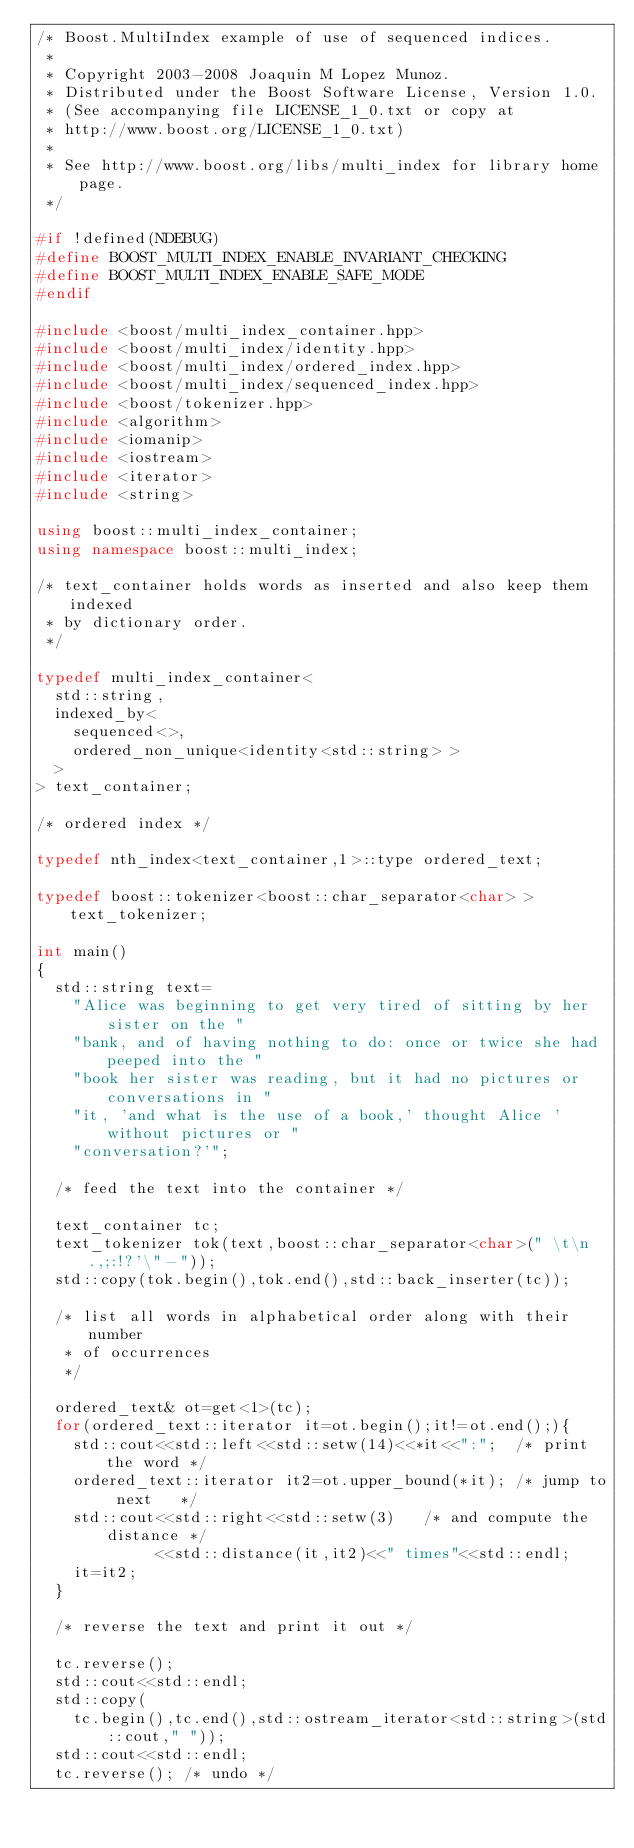<code> <loc_0><loc_0><loc_500><loc_500><_C++_>/* Boost.MultiIndex example of use of sequenced indices.
 *
 * Copyright 2003-2008 Joaquin M Lopez Munoz.
 * Distributed under the Boost Software License, Version 1.0.
 * (See accompanying file LICENSE_1_0.txt or copy at
 * http://www.boost.org/LICENSE_1_0.txt)
 *
 * See http://www.boost.org/libs/multi_index for library home page.
 */

#if !defined(NDEBUG)
#define BOOST_MULTI_INDEX_ENABLE_INVARIANT_CHECKING
#define BOOST_MULTI_INDEX_ENABLE_SAFE_MODE
#endif

#include <boost/multi_index_container.hpp>
#include <boost/multi_index/identity.hpp>
#include <boost/multi_index/ordered_index.hpp>
#include <boost/multi_index/sequenced_index.hpp>
#include <boost/tokenizer.hpp>
#include <algorithm>
#include <iomanip>
#include <iostream>
#include <iterator>
#include <string>

using boost::multi_index_container;
using namespace boost::multi_index;

/* text_container holds words as inserted and also keep them indexed
 * by dictionary order.
 */

typedef multi_index_container<
  std::string,
  indexed_by<
    sequenced<>,
    ordered_non_unique<identity<std::string> >
  >
> text_container;

/* ordered index */

typedef nth_index<text_container,1>::type ordered_text;

typedef boost::tokenizer<boost::char_separator<char> > text_tokenizer;

int main()
{
  std::string text=
    "Alice was beginning to get very tired of sitting by her sister on the "
    "bank, and of having nothing to do: once or twice she had peeped into the "
    "book her sister was reading, but it had no pictures or conversations in "
    "it, 'and what is the use of a book,' thought Alice 'without pictures or "
    "conversation?'";

  /* feed the text into the container */

  text_container tc;
  text_tokenizer tok(text,boost::char_separator<char>(" \t\n.,;:!?'\"-"));
  std::copy(tok.begin(),tok.end(),std::back_inserter(tc));

  /* list all words in alphabetical order along with their number
   * of occurrences
   */

  ordered_text& ot=get<1>(tc);
  for(ordered_text::iterator it=ot.begin();it!=ot.end();){
    std::cout<<std::left<<std::setw(14)<<*it<<":";  /* print the word */
    ordered_text::iterator it2=ot.upper_bound(*it); /* jump to next   */
    std::cout<<std::right<<std::setw(3)   /* and compute the distance */
             <<std::distance(it,it2)<<" times"<<std::endl;
    it=it2;
  }

  /* reverse the text and print it out */

  tc.reverse();
  std::cout<<std::endl;
  std::copy(
    tc.begin(),tc.end(),std::ostream_iterator<std::string>(std::cout," "));
  std::cout<<std::endl;
  tc.reverse(); /* undo */</code> 